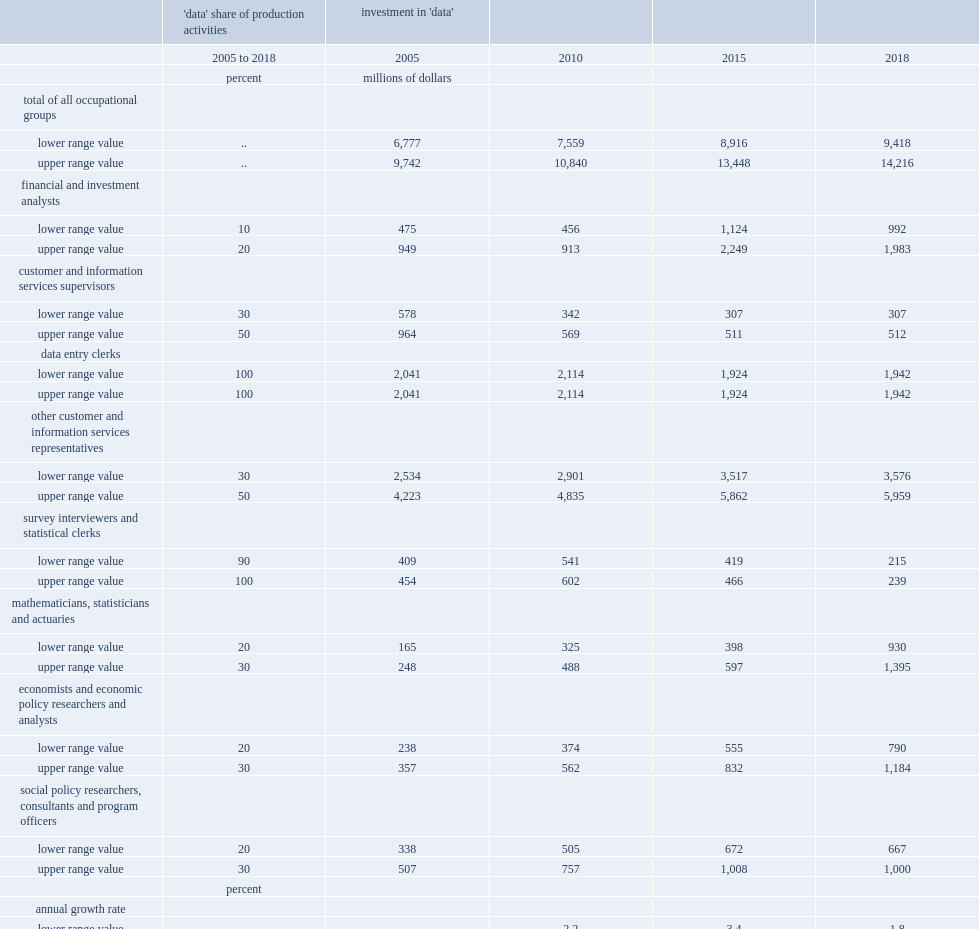In 2018,what were the lower and upper range value of gross fixed capital formation outlays for data(million)respectively? 9418.0 14216.0. 